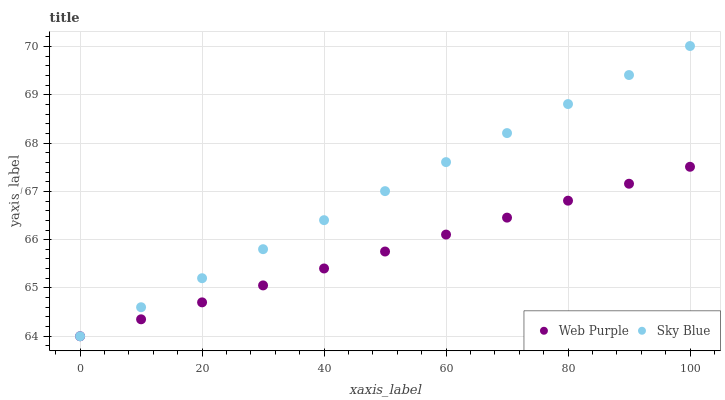Does Web Purple have the minimum area under the curve?
Answer yes or no. Yes. Does Sky Blue have the maximum area under the curve?
Answer yes or no. Yes. Does Web Purple have the maximum area under the curve?
Answer yes or no. No. Is Sky Blue the smoothest?
Answer yes or no. Yes. Is Web Purple the roughest?
Answer yes or no. Yes. Is Web Purple the smoothest?
Answer yes or no. No. Does Sky Blue have the lowest value?
Answer yes or no. Yes. Does Sky Blue have the highest value?
Answer yes or no. Yes. Does Web Purple have the highest value?
Answer yes or no. No. Does Sky Blue intersect Web Purple?
Answer yes or no. Yes. Is Sky Blue less than Web Purple?
Answer yes or no. No. Is Sky Blue greater than Web Purple?
Answer yes or no. No. 